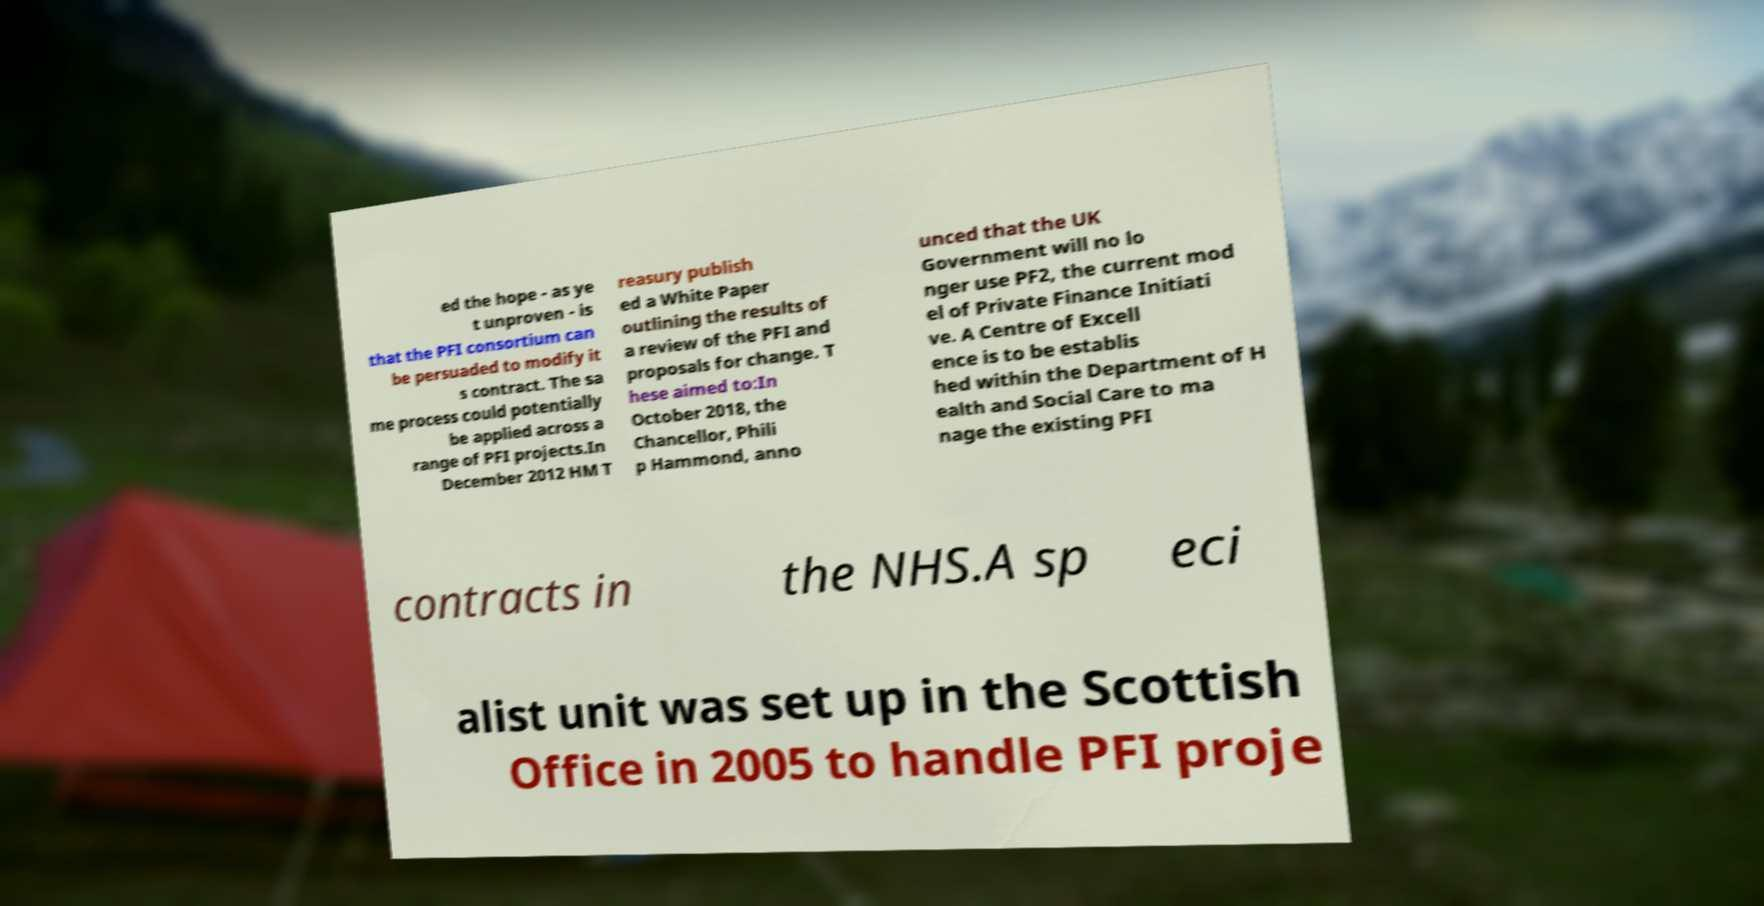I need the written content from this picture converted into text. Can you do that? ed the hope - as ye t unproven - is that the PFI consortium can be persuaded to modify it s contract. The sa me process could potentially be applied across a range of PFI projects.In December 2012 HM T reasury publish ed a White Paper outlining the results of a review of the PFI and proposals for change. T hese aimed to:In October 2018, the Chancellor, Phili p Hammond, anno unced that the UK Government will no lo nger use PF2, the current mod el of Private Finance Initiati ve. A Centre of Excell ence is to be establis hed within the Department of H ealth and Social Care to ma nage the existing PFI contracts in the NHS.A sp eci alist unit was set up in the Scottish Office in 2005 to handle PFI proje 